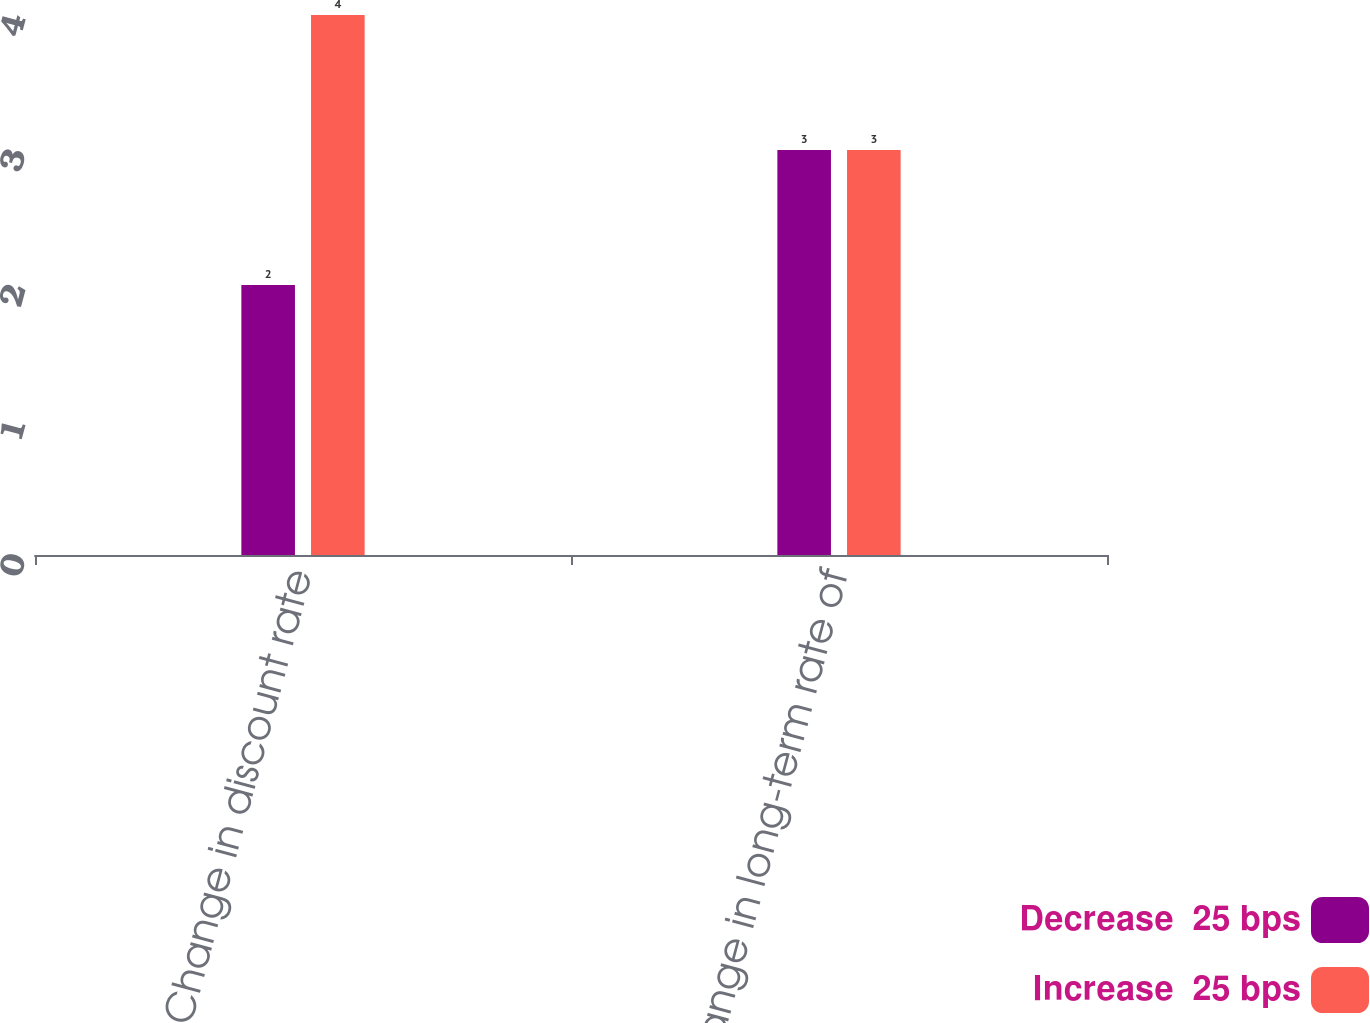<chart> <loc_0><loc_0><loc_500><loc_500><stacked_bar_chart><ecel><fcel>Change in discount rate<fcel>Change in long-term rate of<nl><fcel>Decrease  25 bps<fcel>2<fcel>3<nl><fcel>Increase  25 bps<fcel>4<fcel>3<nl></chart> 